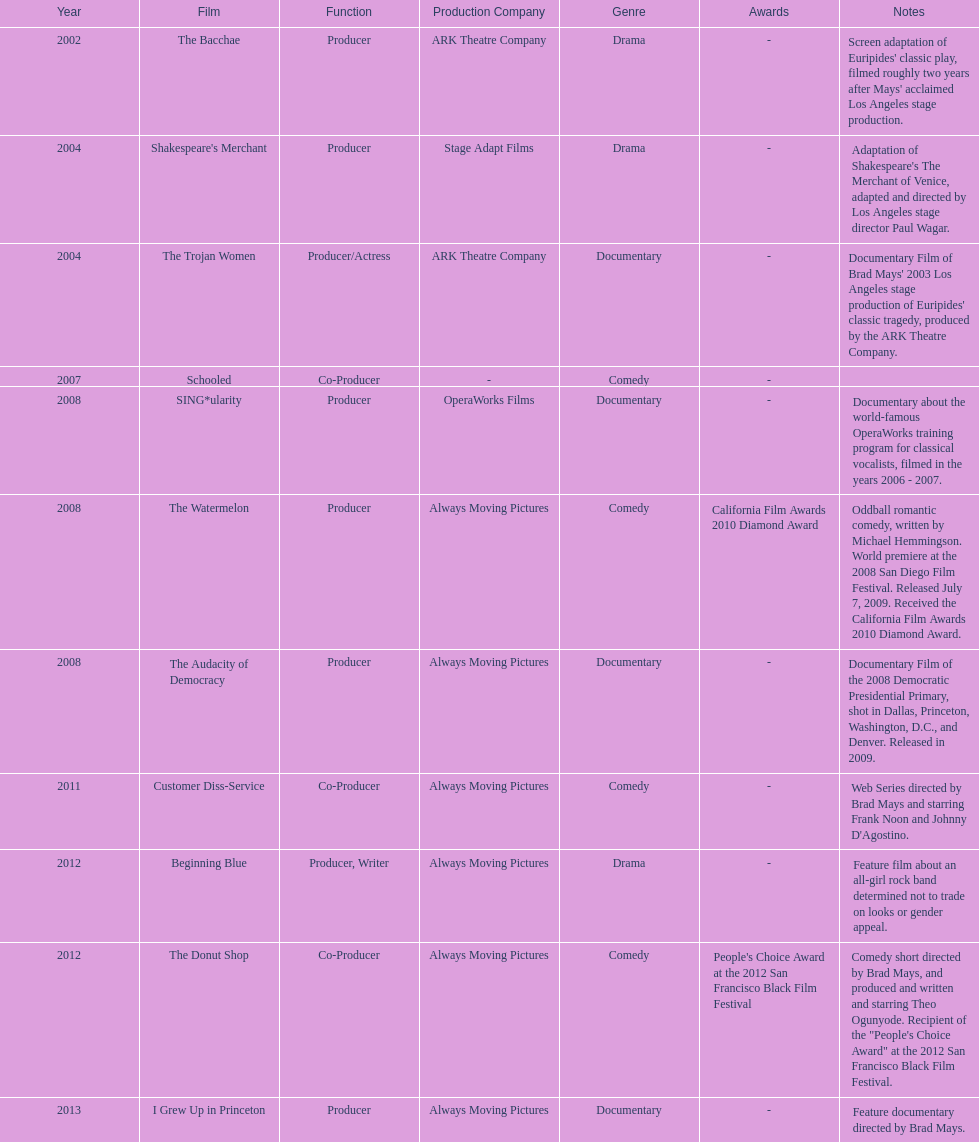How many years before was the film bacchae out before the watermelon? 6. 